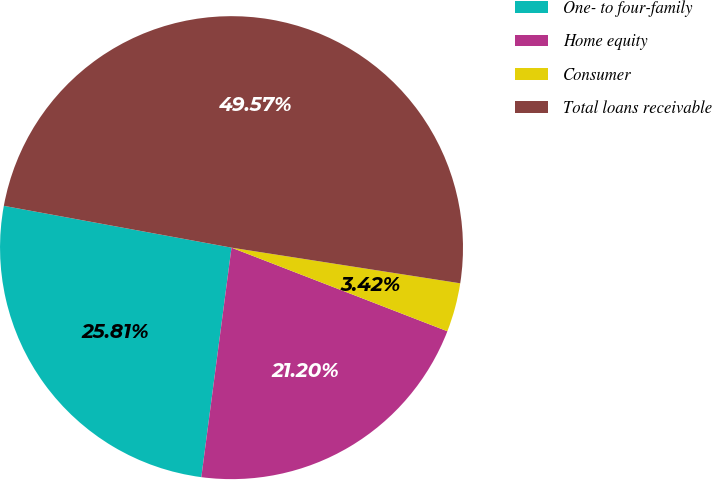<chart> <loc_0><loc_0><loc_500><loc_500><pie_chart><fcel>One- to four-family<fcel>Home equity<fcel>Consumer<fcel>Total loans receivable<nl><fcel>25.81%<fcel>21.2%<fcel>3.42%<fcel>49.57%<nl></chart> 